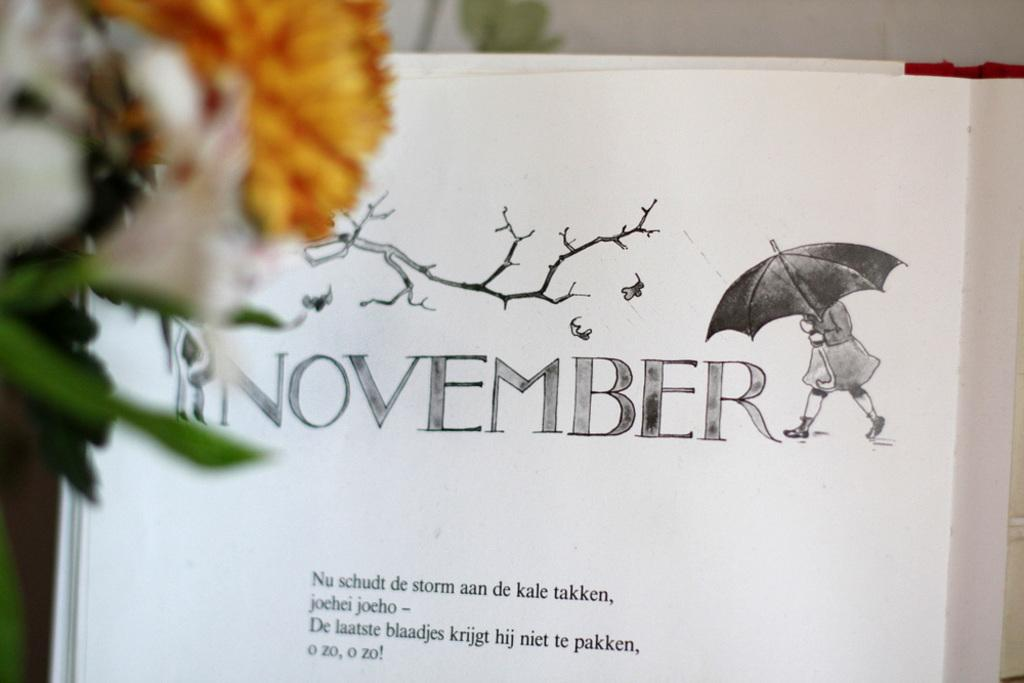What type of plant is on the left side of the image? There is a flower plant on the left side of the image. What object is located in the middle of the image? There is a book in the middle of the image. What can be found on the book? The book has text on it. What type of rule is being tested in the image? There is no rule or test present in the image; it features a flower plant and a book with text. What part of the book is being highlighted in the image? There is no specific part of the book being highlighted in the image; the book is simply present with text on it. 